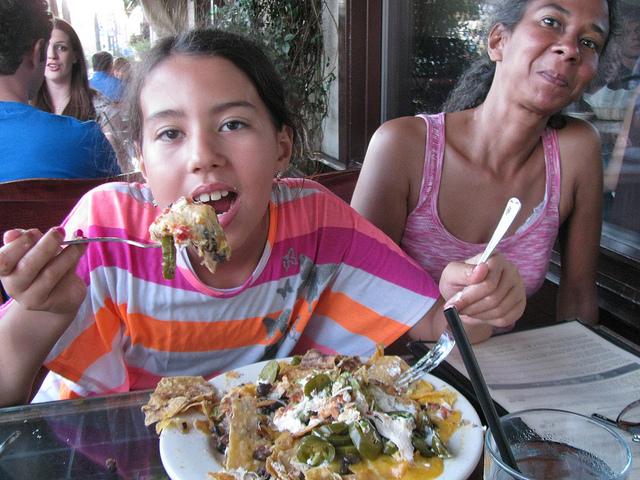What is the child eating in this picture?
Keep it brief. Nachos. Is the older person nervous about having her picture taken?
Give a very brief answer. Yes. What is the child doing?
Be succinct. Eating. Is the woman wearing make-up?
Concise answer only. No. 